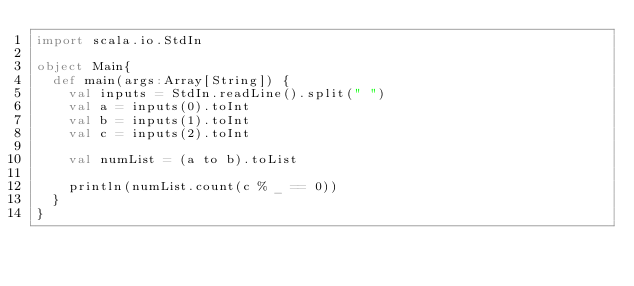<code> <loc_0><loc_0><loc_500><loc_500><_Scala_>import scala.io.StdIn

object Main{
  def main(args:Array[String]) {
    val inputs = StdIn.readLine().split(" ")
    val a = inputs(0).toInt
    val b = inputs(1).toInt
    val c = inputs(2).toInt
    
    val numList = (a to b).toList
    
    println(numList.count(c % _ == 0))
  }
}</code> 